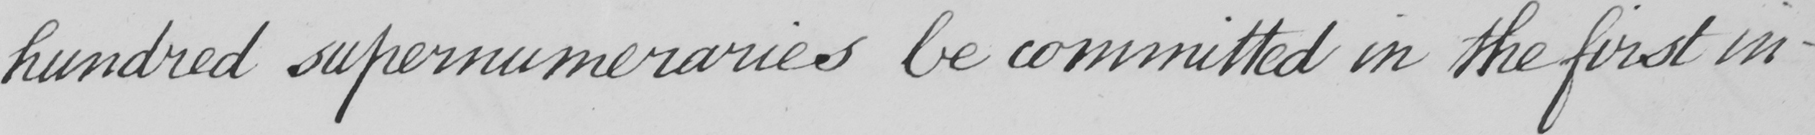Transcribe the text shown in this historical manuscript line. hundred supernumeraries be committed in the first in- 